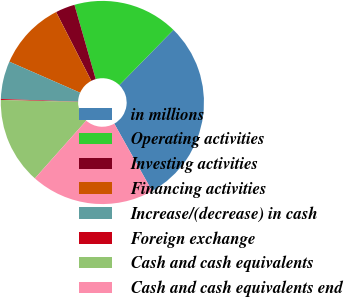Convert chart. <chart><loc_0><loc_0><loc_500><loc_500><pie_chart><fcel>in millions<fcel>Operating activities<fcel>Investing activities<fcel>Financing activities<fcel>Increase/(decrease) in cash<fcel>Foreign exchange<fcel>Cash and cash equivalents<fcel>Cash and cash equivalents end<nl><fcel>29.52%<fcel>16.77%<fcel>3.09%<fcel>10.9%<fcel>6.03%<fcel>0.15%<fcel>13.83%<fcel>19.71%<nl></chart> 